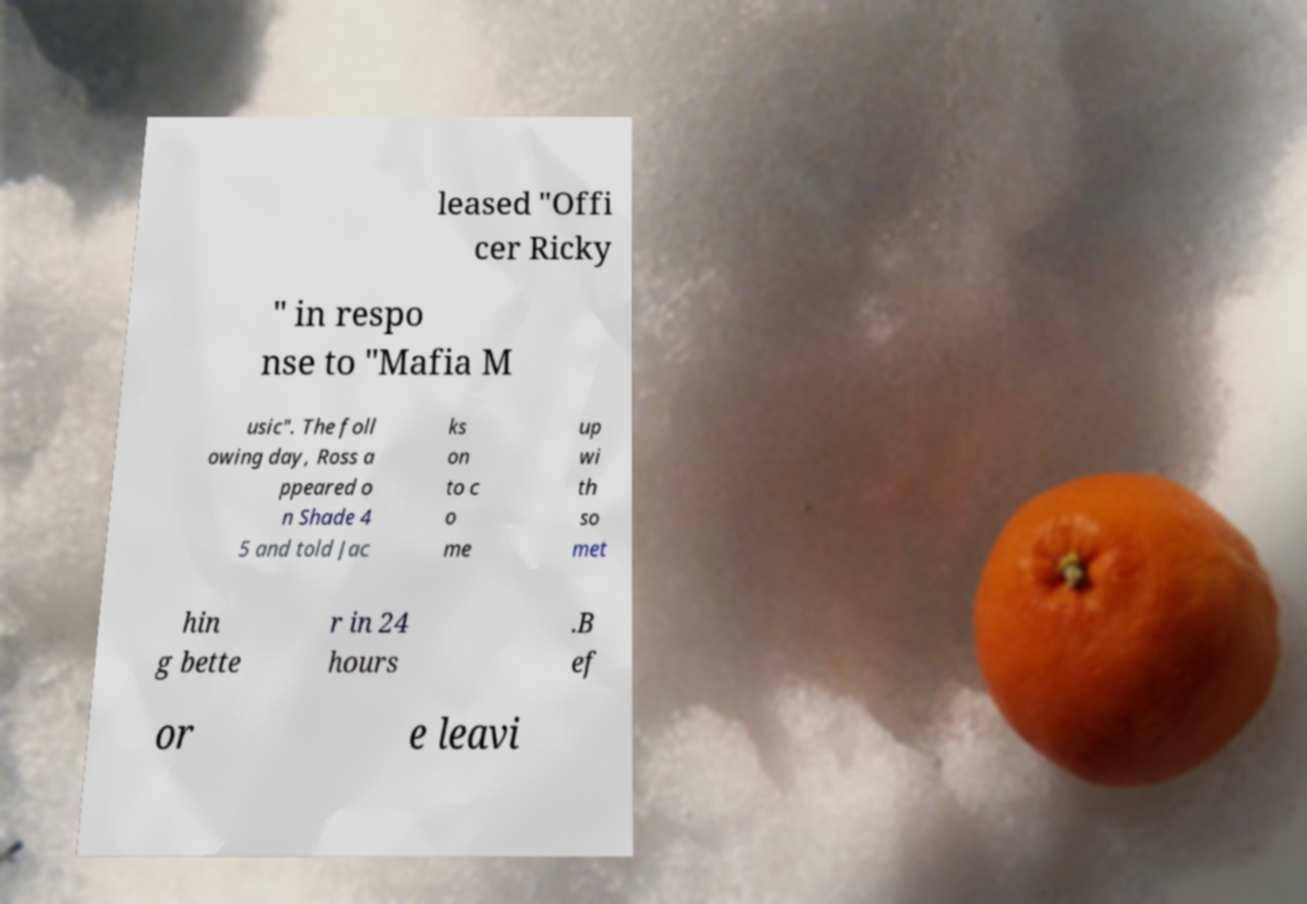Can you accurately transcribe the text from the provided image for me? leased "Offi cer Ricky " in respo nse to "Mafia M usic". The foll owing day, Ross a ppeared o n Shade 4 5 and told Jac ks on to c o me up wi th so met hin g bette r in 24 hours .B ef or e leavi 